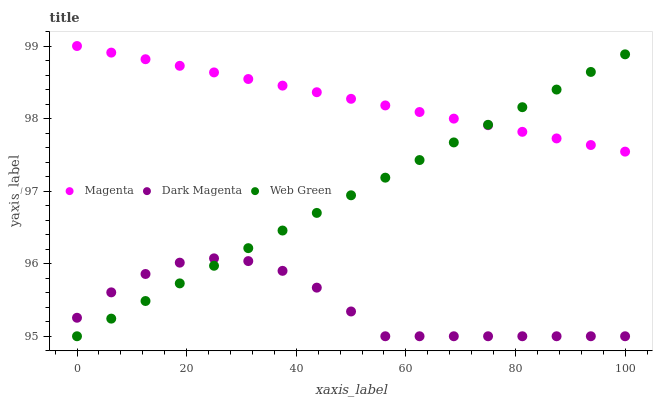Does Dark Magenta have the minimum area under the curve?
Answer yes or no. Yes. Does Magenta have the maximum area under the curve?
Answer yes or no. Yes. Does Web Green have the minimum area under the curve?
Answer yes or no. No. Does Web Green have the maximum area under the curve?
Answer yes or no. No. Is Web Green the smoothest?
Answer yes or no. Yes. Is Dark Magenta the roughest?
Answer yes or no. Yes. Is Dark Magenta the smoothest?
Answer yes or no. No. Is Web Green the roughest?
Answer yes or no. No. Does Dark Magenta have the lowest value?
Answer yes or no. Yes. Does Magenta have the highest value?
Answer yes or no. Yes. Does Web Green have the highest value?
Answer yes or no. No. Is Dark Magenta less than Magenta?
Answer yes or no. Yes. Is Magenta greater than Dark Magenta?
Answer yes or no. Yes. Does Web Green intersect Dark Magenta?
Answer yes or no. Yes. Is Web Green less than Dark Magenta?
Answer yes or no. No. Is Web Green greater than Dark Magenta?
Answer yes or no. No. Does Dark Magenta intersect Magenta?
Answer yes or no. No. 